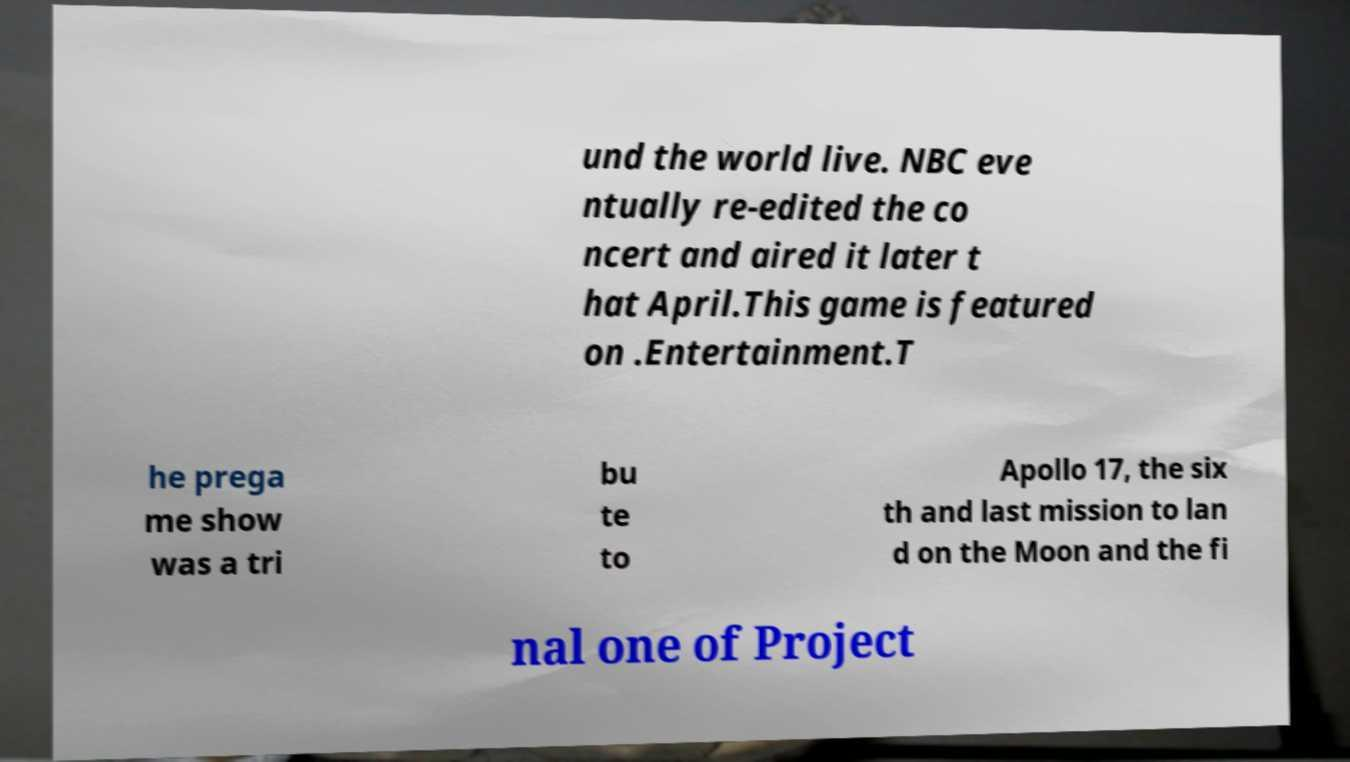What messages or text are displayed in this image? I need them in a readable, typed format. und the world live. NBC eve ntually re-edited the co ncert and aired it later t hat April.This game is featured on .Entertainment.T he prega me show was a tri bu te to Apollo 17, the six th and last mission to lan d on the Moon and the fi nal one of Project 